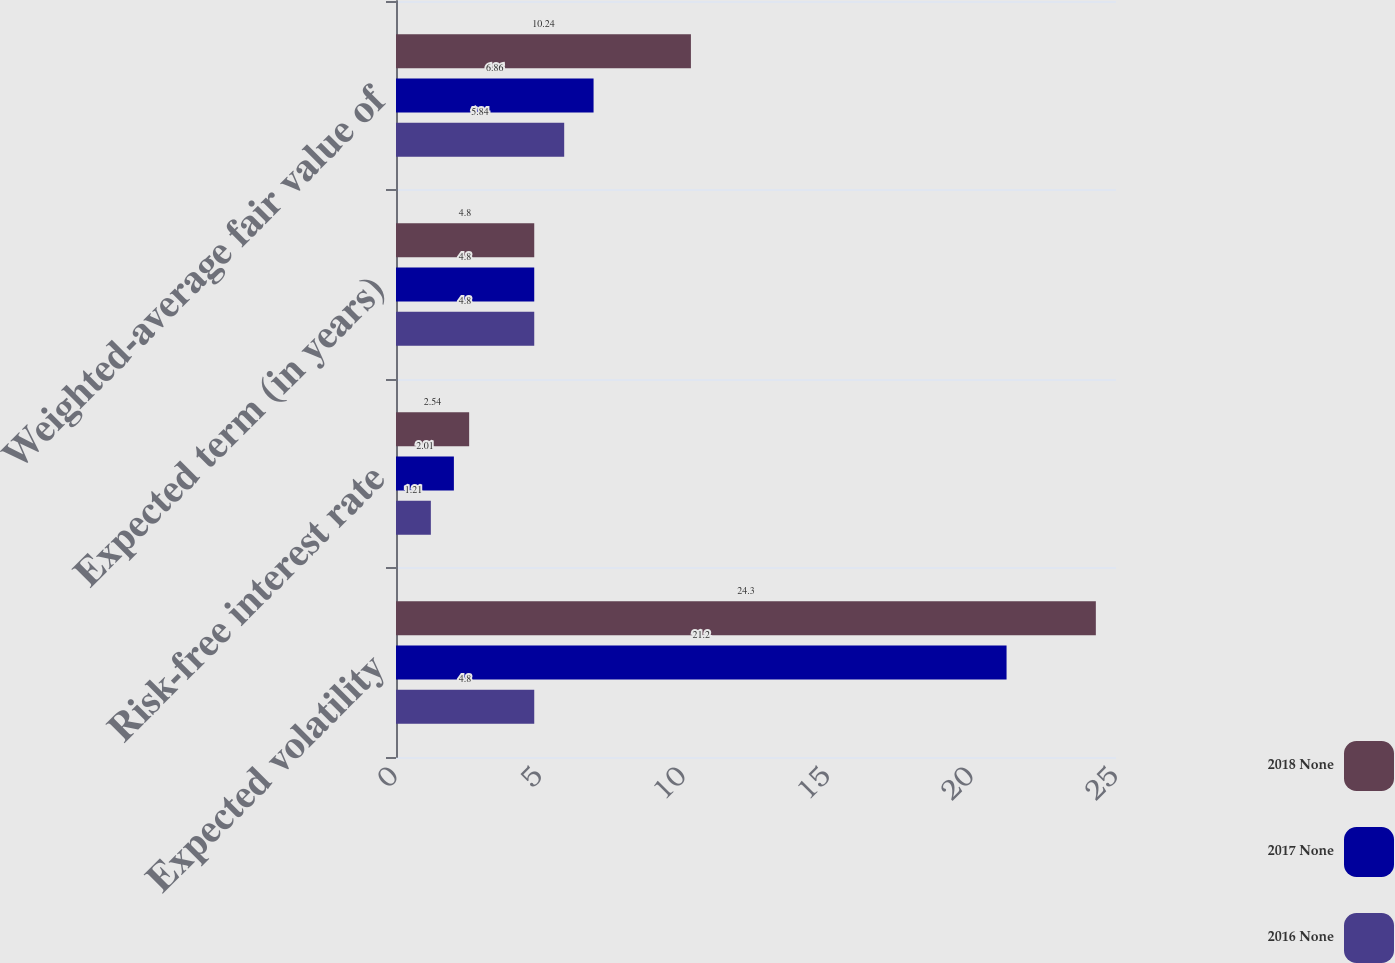Convert chart to OTSL. <chart><loc_0><loc_0><loc_500><loc_500><stacked_bar_chart><ecel><fcel>Expected volatility<fcel>Risk-free interest rate<fcel>Expected term (in years)<fcel>Weighted-average fair value of<nl><fcel>2018 None<fcel>24.3<fcel>2.54<fcel>4.8<fcel>10.24<nl><fcel>2017 None<fcel>21.2<fcel>2.01<fcel>4.8<fcel>6.86<nl><fcel>2016 None<fcel>4.8<fcel>1.21<fcel>4.8<fcel>5.84<nl></chart> 